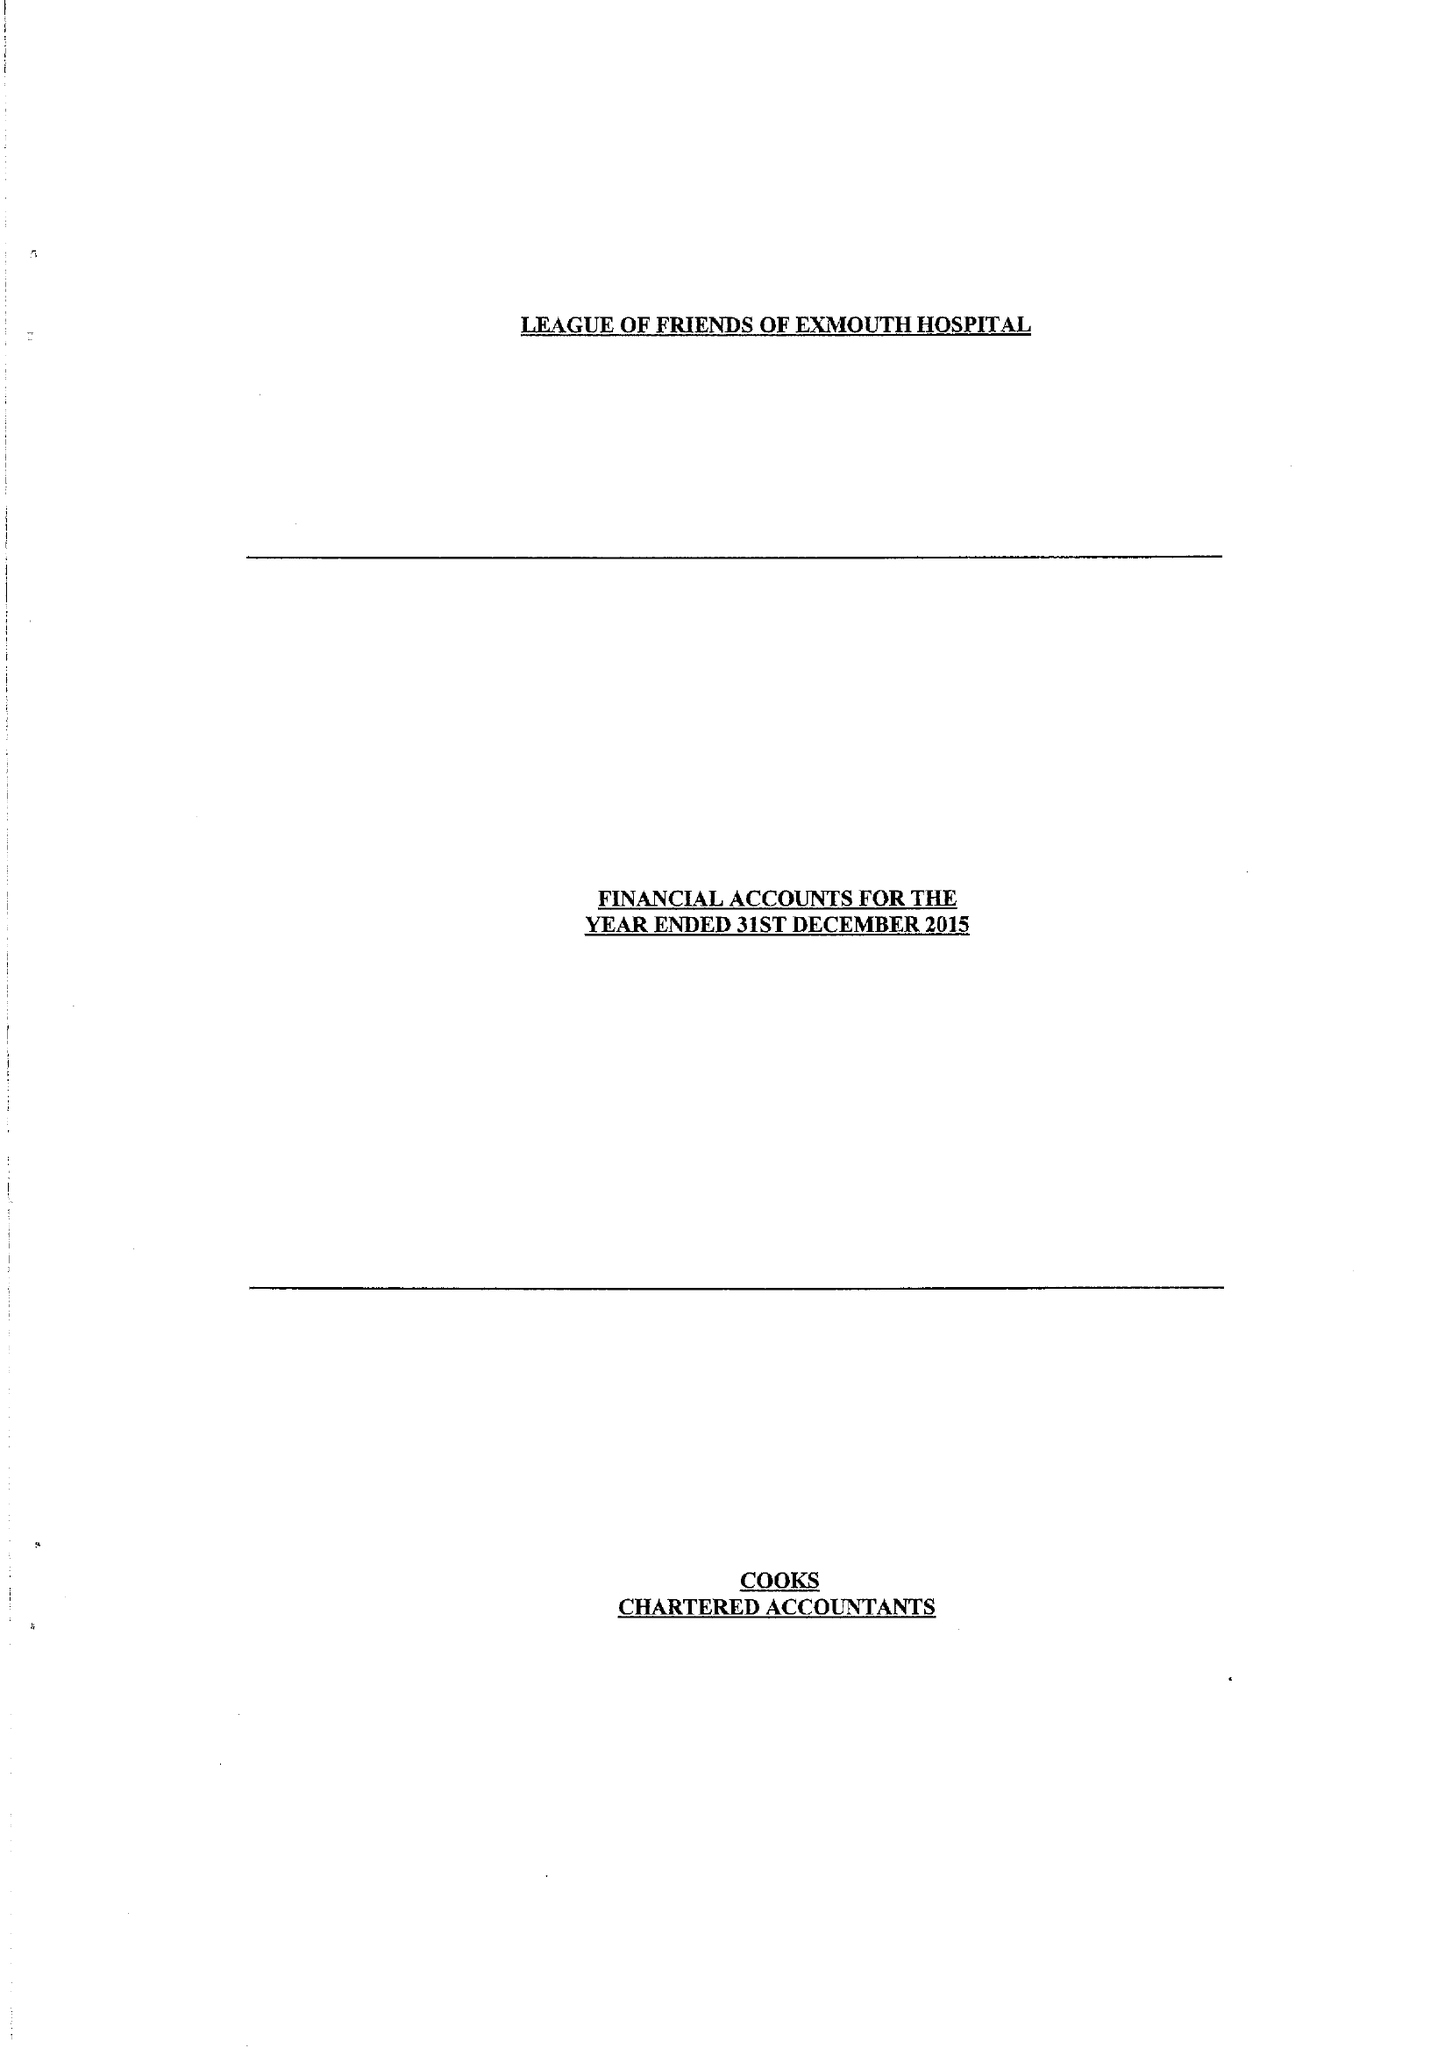What is the value for the charity_name?
Answer the question using a single word or phrase. The League Of Friends Of The Exmouth Hospital 